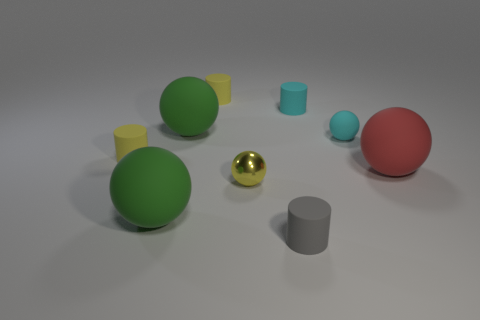There is a big green rubber object that is on the right side of the green object in front of the small matte sphere; what shape is it?
Your response must be concise. Sphere. What number of other yellow spheres have the same material as the yellow sphere?
Offer a terse response. 0. What color is the small ball that is made of the same material as the small gray cylinder?
Your answer should be very brief. Cyan. How big is the green thing in front of the big green sphere behind the tiny ball left of the tiny cyan ball?
Provide a short and direct response. Large. Is the number of cyan matte objects less than the number of tiny brown rubber cylinders?
Ensure brevity in your answer.  No. There is a tiny matte object that is the same shape as the big red rubber object; what color is it?
Ensure brevity in your answer.  Cyan. Are there any big red rubber things that are on the left side of the tiny yellow rubber object behind the small cyan rubber object that is behind the cyan ball?
Provide a short and direct response. No. Is the shape of the red object the same as the tiny gray matte thing?
Make the answer very short. No. Is the number of cyan rubber spheres that are in front of the red rubber ball less than the number of big rubber objects?
Provide a short and direct response. Yes. There is a tiny rubber sphere in front of the tiny matte cylinder to the right of the cylinder in front of the tiny yellow sphere; what is its color?
Your answer should be compact. Cyan. 